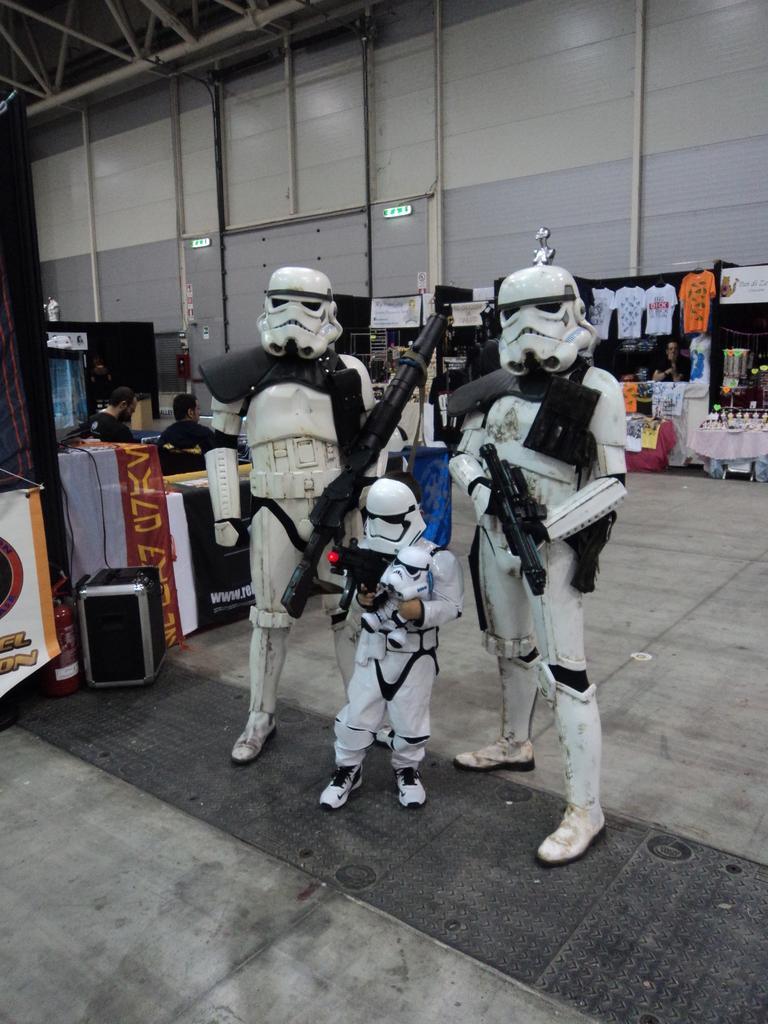Describe this image in one or two sentences. In the center of the image there are robots and we can see tables. We can see people sitting and there are stalls. There are clothes. In the background there is a wall and pipes. 